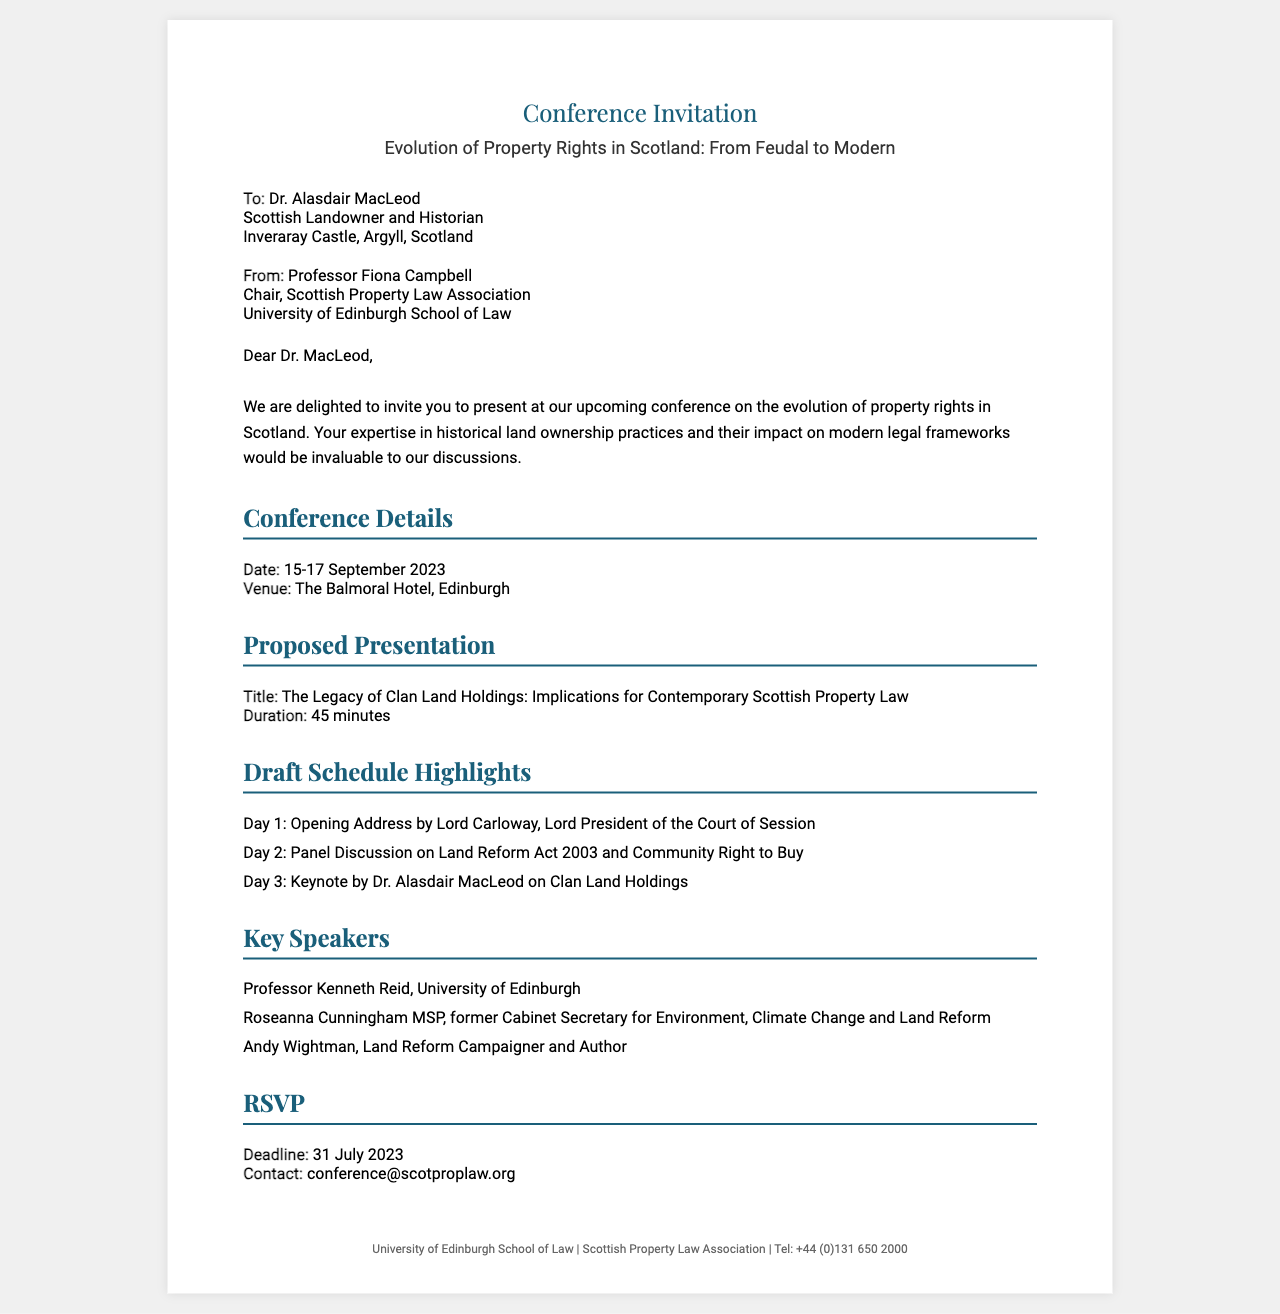What is the title of the conference? The title is stated in the fax header as the main focus of the event.
Answer: Evolution of Property Rights in Scotland: From Feudal to Modern Who is the recipient of the fax? The recipient's details are provided in the document under the recipient section.
Answer: Dr. Alasdair MacLeod What is the proposed presentation title? The title of the proposed presentation is mentioned in the presentation details section.
Answer: The Legacy of Clan Land Holdings: Implications for Contemporary Scottish Property Law What is the conference date? The date is specified in the conference details section.
Answer: 15-17 September 2023 Who is giving the opening address? The name of the speaker for the opening address is listed in the draft schedule highlights.
Answer: Lord Carloway What is the RSVP deadline? The deadline for RSVP is provided in the RSVP section of the document.
Answer: 31 July 2023 Which university is hosting the conference? The hosting university is mentioned in the sender's details.
Answer: University of Edinburgh How long is the proposed presentation? The duration of the presentation is specified in the presentation details section.
Answer: 45 minutes Name one of the key speakers. The names of key speakers are listed in the speakers section.
Answer: Professor Kenneth Reid 